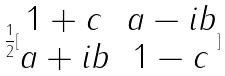<formula> <loc_0><loc_0><loc_500><loc_500>\frac { 1 } { 2 } [ \begin{matrix} 1 + c & a - i b \\ a + i b & 1 - c \end{matrix} ]</formula> 